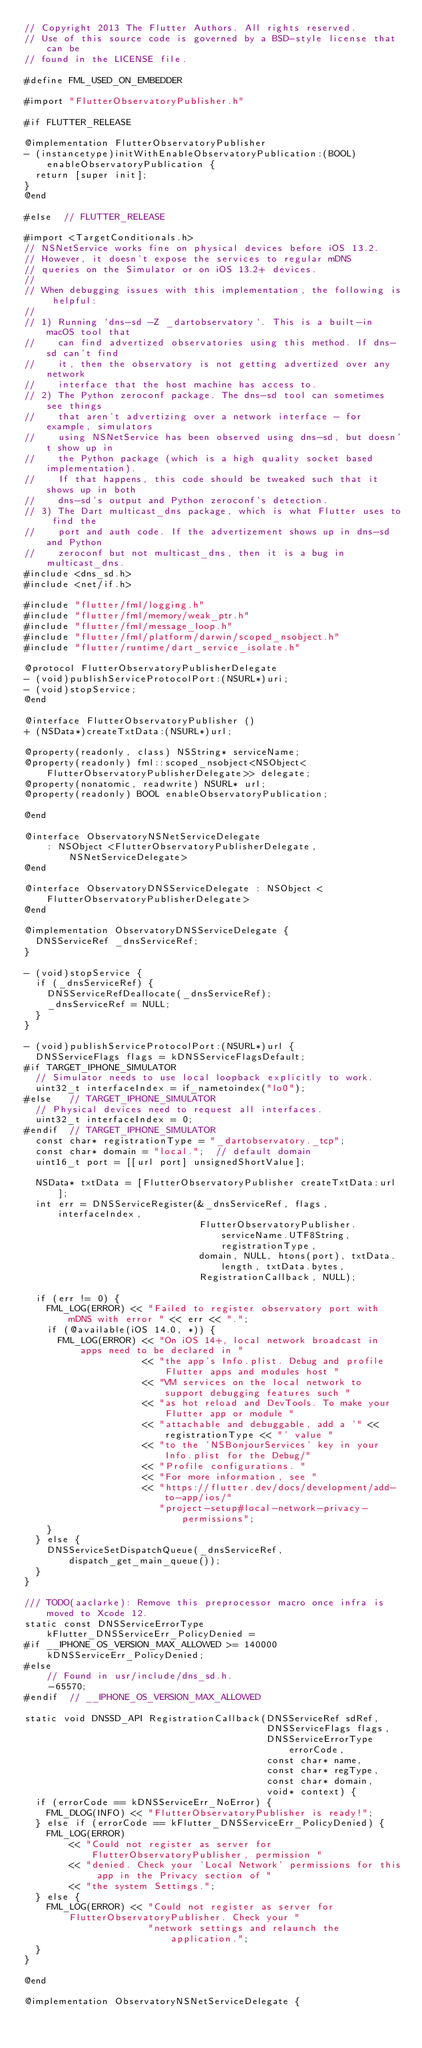<code> <loc_0><loc_0><loc_500><loc_500><_ObjectiveC_>// Copyright 2013 The Flutter Authors. All rights reserved.
// Use of this source code is governed by a BSD-style license that can be
// found in the LICENSE file.

#define FML_USED_ON_EMBEDDER

#import "FlutterObservatoryPublisher.h"

#if FLUTTER_RELEASE

@implementation FlutterObservatoryPublisher
- (instancetype)initWithEnableObservatoryPublication:(BOOL)enableObservatoryPublication {
  return [super init];
}
@end

#else  // FLUTTER_RELEASE

#import <TargetConditionals.h>
// NSNetService works fine on physical devices before iOS 13.2.
// However, it doesn't expose the services to regular mDNS
// queries on the Simulator or on iOS 13.2+ devices.
//
// When debugging issues with this implementation, the following is helpful:
//
// 1) Running `dns-sd -Z _dartobservatory`. This is a built-in macOS tool that
//    can find advertized observatories using this method. If dns-sd can't find
//    it, then the observatory is not getting advertized over any network
//    interface that the host machine has access to.
// 2) The Python zeroconf package. The dns-sd tool can sometimes see things
//    that aren't advertizing over a network interface - for example, simulators
//    using NSNetService has been observed using dns-sd, but doesn't show up in
//    the Python package (which is a high quality socket based implementation).
//    If that happens, this code should be tweaked such that it shows up in both
//    dns-sd's output and Python zeroconf's detection.
// 3) The Dart multicast_dns package, which is what Flutter uses to find the
//    port and auth code. If the advertizement shows up in dns-sd and Python
//    zeroconf but not multicast_dns, then it is a bug in multicast_dns.
#include <dns_sd.h>
#include <net/if.h>

#include "flutter/fml/logging.h"
#include "flutter/fml/memory/weak_ptr.h"
#include "flutter/fml/message_loop.h"
#include "flutter/fml/platform/darwin/scoped_nsobject.h"
#include "flutter/runtime/dart_service_isolate.h"

@protocol FlutterObservatoryPublisherDelegate
- (void)publishServiceProtocolPort:(NSURL*)uri;
- (void)stopService;
@end

@interface FlutterObservatoryPublisher ()
+ (NSData*)createTxtData:(NSURL*)url;

@property(readonly, class) NSString* serviceName;
@property(readonly) fml::scoped_nsobject<NSObject<FlutterObservatoryPublisherDelegate>> delegate;
@property(nonatomic, readwrite) NSURL* url;
@property(readonly) BOOL enableObservatoryPublication;

@end

@interface ObservatoryNSNetServiceDelegate
    : NSObject <FlutterObservatoryPublisherDelegate, NSNetServiceDelegate>
@end

@interface ObservatoryDNSServiceDelegate : NSObject <FlutterObservatoryPublisherDelegate>
@end

@implementation ObservatoryDNSServiceDelegate {
  DNSServiceRef _dnsServiceRef;
}

- (void)stopService {
  if (_dnsServiceRef) {
    DNSServiceRefDeallocate(_dnsServiceRef);
    _dnsServiceRef = NULL;
  }
}

- (void)publishServiceProtocolPort:(NSURL*)url {
  DNSServiceFlags flags = kDNSServiceFlagsDefault;
#if TARGET_IPHONE_SIMULATOR
  // Simulator needs to use local loopback explicitly to work.
  uint32_t interfaceIndex = if_nametoindex("lo0");
#else   // TARGET_IPHONE_SIMULATOR
  // Physical devices need to request all interfaces.
  uint32_t interfaceIndex = 0;
#endif  // TARGET_IPHONE_SIMULATOR
  const char* registrationType = "_dartobservatory._tcp";
  const char* domain = "local.";  // default domain
  uint16_t port = [[url port] unsignedShortValue];

  NSData* txtData = [FlutterObservatoryPublisher createTxtData:url];
  int err = DNSServiceRegister(&_dnsServiceRef, flags, interfaceIndex,
                               FlutterObservatoryPublisher.serviceName.UTF8String, registrationType,
                               domain, NULL, htons(port), txtData.length, txtData.bytes,
                               RegistrationCallback, NULL);

  if (err != 0) {
    FML_LOG(ERROR) << "Failed to register observatory port with mDNS with error " << err << ".";
    if (@available(iOS 14.0, *)) {
      FML_LOG(ERROR) << "On iOS 14+, local network broadcast in apps need to be declared in "
                     << "the app's Info.plist. Debug and profile Flutter apps and modules host "
                     << "VM services on the local network to support debugging features such "
                     << "as hot reload and DevTools. To make your Flutter app or module "
                     << "attachable and debuggable, add a '" << registrationType << "' value "
                     << "to the 'NSBonjourServices' key in your Info.plist for the Debug/"
                     << "Profile configurations. "
                     << "For more information, see "
                     << "https://flutter.dev/docs/development/add-to-app/ios/"
                        "project-setup#local-network-privacy-permissions";
    }
  } else {
    DNSServiceSetDispatchQueue(_dnsServiceRef, dispatch_get_main_queue());
  }
}

/// TODO(aaclarke): Remove this preprocessor macro once infra is moved to Xcode 12.
static const DNSServiceErrorType kFlutter_DNSServiceErr_PolicyDenied =
#if __IPHONE_OS_VERSION_MAX_ALLOWED >= 140000
    kDNSServiceErr_PolicyDenied;
#else
    // Found in usr/include/dns_sd.h.
    -65570;
#endif  // __IPHONE_OS_VERSION_MAX_ALLOWED

static void DNSSD_API RegistrationCallback(DNSServiceRef sdRef,
                                           DNSServiceFlags flags,
                                           DNSServiceErrorType errorCode,
                                           const char* name,
                                           const char* regType,
                                           const char* domain,
                                           void* context) {
  if (errorCode == kDNSServiceErr_NoError) {
    FML_DLOG(INFO) << "FlutterObservatoryPublisher is ready!";
  } else if (errorCode == kFlutter_DNSServiceErr_PolicyDenied) {
    FML_LOG(ERROR)
        << "Could not register as server for FlutterObservatoryPublisher, permission "
        << "denied. Check your 'Local Network' permissions for this app in the Privacy section of "
        << "the system Settings.";
  } else {
    FML_LOG(ERROR) << "Could not register as server for FlutterObservatoryPublisher. Check your "
                      "network settings and relaunch the application.";
  }
}

@end

@implementation ObservatoryNSNetServiceDelegate {</code> 